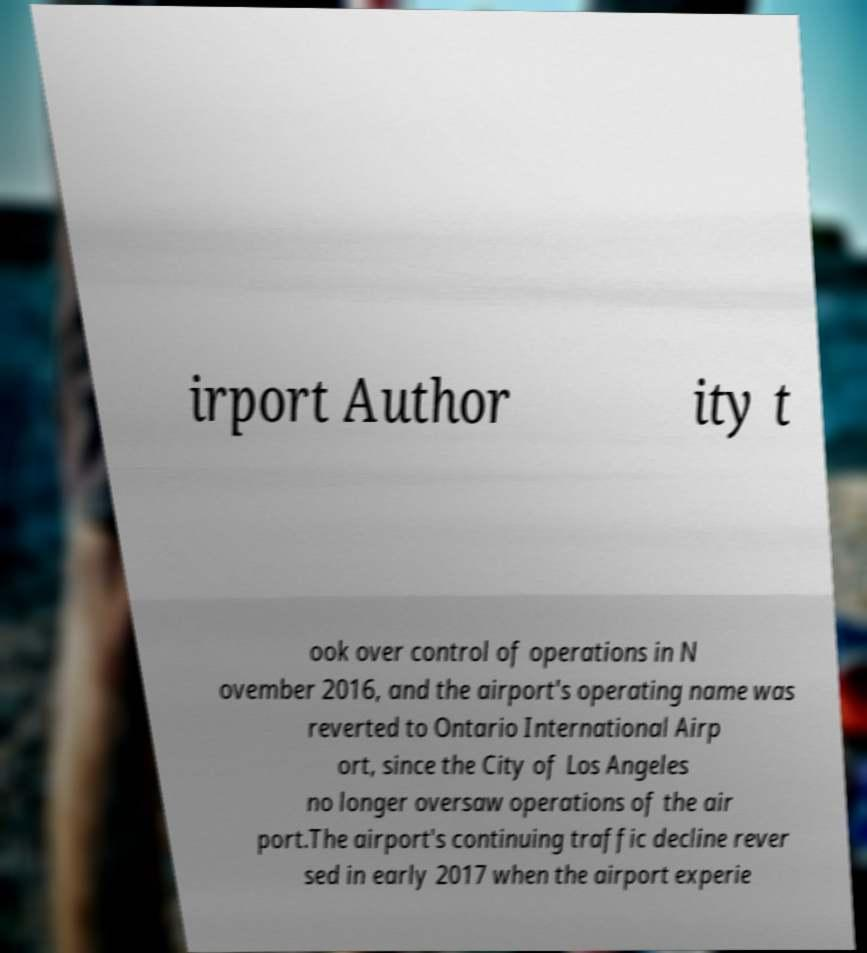Please read and relay the text visible in this image. What does it say? irport Author ity t ook over control of operations in N ovember 2016, and the airport's operating name was reverted to Ontario International Airp ort, since the City of Los Angeles no longer oversaw operations of the air port.The airport's continuing traffic decline rever sed in early 2017 when the airport experie 